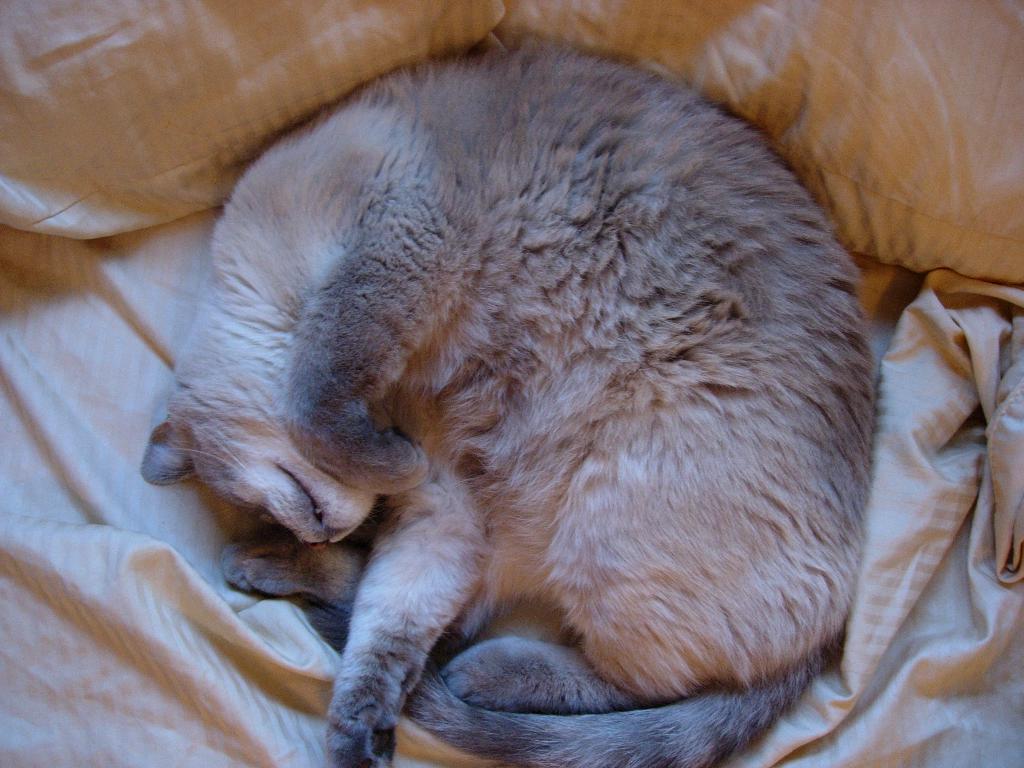Could you give a brief overview of what you see in this image? In this picture i can see Cat is sleeping 